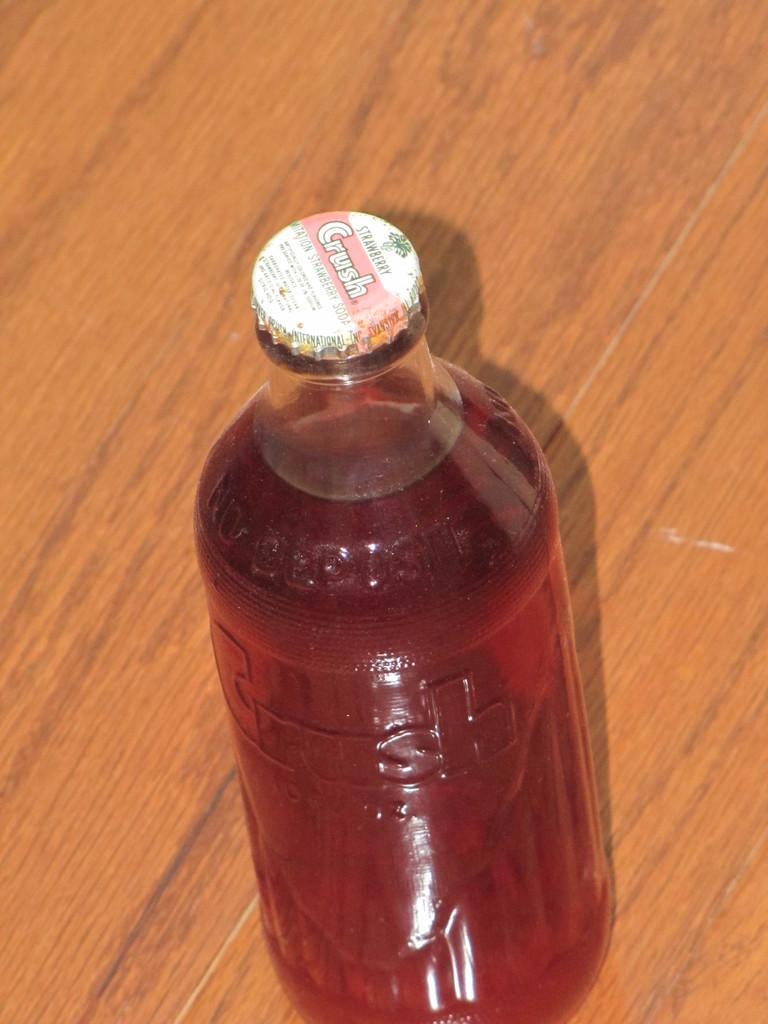What kind of drink is in this bottle?
Provide a short and direct response. Crush. What flavor is this drink?
Give a very brief answer. Strawberry. 